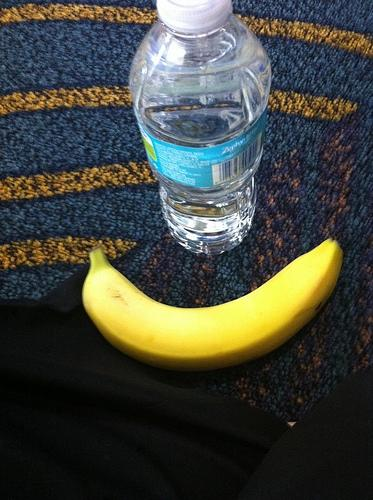Describe the main objects in the picture and their visual appeal. A ripe, eye-catching yellow banana with a green tip is placed on a visually striking blue and yellow striped carpet, alongside a refreshingly clear water bottle with a blue label and white cap. Identify the primary objects in the image while emphasizing their simplicity. A plain yellow banana and a basic water bottle with a blue label rest casually upon a blue and yellow striped carpet. Comment on the image, focusing on the water bottle and its features. A clear water bottle with a white plastic cap and a blue label decorated with a barcode, stands next to a yellow banana on a multi-colored carpet. Summarize the scene in the image and specify the subject location. A yellow banana lies on the left side of a vibrant blue and yellow striped carpet near a water bottle with a white cap on the right. Discuss the arrangement of objects and the color contrast in the image. The image displays a pleasing contrast between the bright yellow banana and the blue and yellow striped carpet, complemented by the presence of a clear water bottle with a blue label. Describe the image focusing on the banana and its condition. A long yellow banana, with a green stem and some brown spots, rests on a colorful carpet next to a water bottle. Provide a brief overview of the key elements in the image. A yellow banana with a green tip sits on a blue and yellow striped carpet next to a water bottle with a blue label and white cap. Explain the scene in the image, focusing on the carpet's design and colors. A multicolored carpet with blue and yellow stripes creates a vibrant backdrop for a ripe yellow banana and a water bottle with blue label and white cap. Mention the primary items in the image and their colors. The image features a yellow banana, a blue and yellow carpet, and a water bottle with a white cap and blue label. Narrate the setting and elements in the image using descriptive language. Nestled upon a vivid, multi-colored carpet, a ripe yellow banana with a verdant stem lies invitingly alongside a crystal-clear water bottle, adorned with an azure label and pristine white cap. 